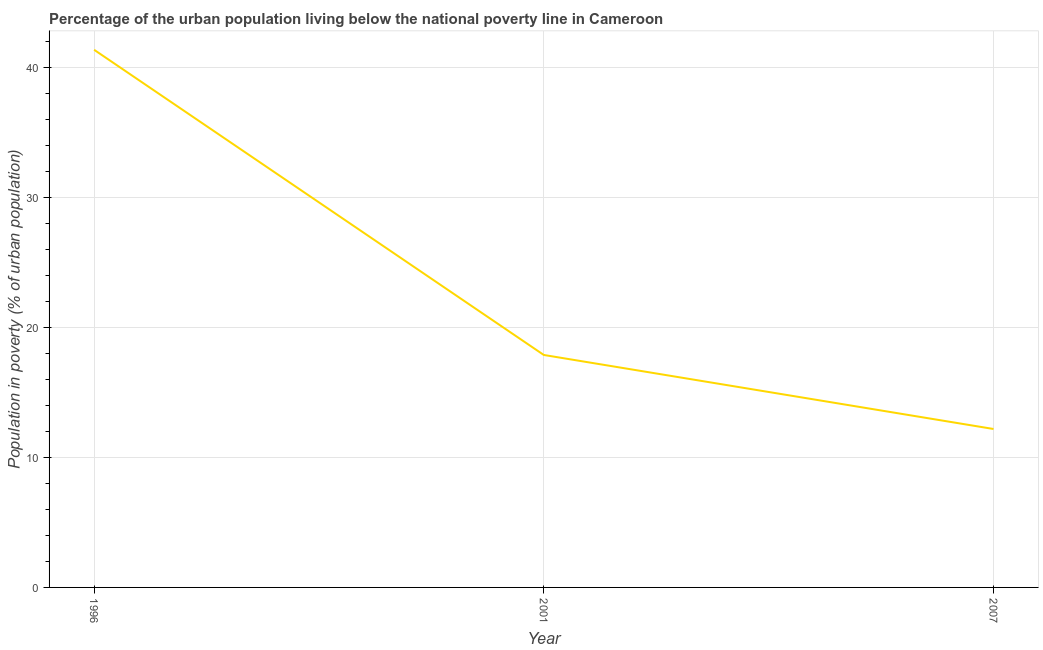What is the percentage of urban population living below poverty line in 1996?
Provide a short and direct response. 41.4. Across all years, what is the maximum percentage of urban population living below poverty line?
Your answer should be compact. 41.4. In which year was the percentage of urban population living below poverty line maximum?
Keep it short and to the point. 1996. In which year was the percentage of urban population living below poverty line minimum?
Provide a short and direct response. 2007. What is the sum of the percentage of urban population living below poverty line?
Your answer should be very brief. 71.5. What is the difference between the percentage of urban population living below poverty line in 1996 and 2007?
Your answer should be very brief. 29.2. What is the average percentage of urban population living below poverty line per year?
Offer a terse response. 23.83. What is the median percentage of urban population living below poverty line?
Keep it short and to the point. 17.9. In how many years, is the percentage of urban population living below poverty line greater than 18 %?
Keep it short and to the point. 1. Do a majority of the years between 1996 and 2007 (inclusive) have percentage of urban population living below poverty line greater than 6 %?
Make the answer very short. Yes. What is the ratio of the percentage of urban population living below poverty line in 2001 to that in 2007?
Give a very brief answer. 1.47. Is the sum of the percentage of urban population living below poverty line in 1996 and 2001 greater than the maximum percentage of urban population living below poverty line across all years?
Make the answer very short. Yes. What is the difference between the highest and the lowest percentage of urban population living below poverty line?
Make the answer very short. 29.2. In how many years, is the percentage of urban population living below poverty line greater than the average percentage of urban population living below poverty line taken over all years?
Your response must be concise. 1. Does the percentage of urban population living below poverty line monotonically increase over the years?
Provide a short and direct response. No. How many lines are there?
Provide a succinct answer. 1. What is the difference between two consecutive major ticks on the Y-axis?
Keep it short and to the point. 10. Are the values on the major ticks of Y-axis written in scientific E-notation?
Provide a succinct answer. No. What is the title of the graph?
Offer a very short reply. Percentage of the urban population living below the national poverty line in Cameroon. What is the label or title of the Y-axis?
Provide a short and direct response. Population in poverty (% of urban population). What is the Population in poverty (% of urban population) of 1996?
Offer a terse response. 41.4. What is the Population in poverty (% of urban population) of 2007?
Your answer should be compact. 12.2. What is the difference between the Population in poverty (% of urban population) in 1996 and 2001?
Give a very brief answer. 23.5. What is the difference between the Population in poverty (% of urban population) in 1996 and 2007?
Provide a short and direct response. 29.2. What is the ratio of the Population in poverty (% of urban population) in 1996 to that in 2001?
Your answer should be very brief. 2.31. What is the ratio of the Population in poverty (% of urban population) in 1996 to that in 2007?
Offer a very short reply. 3.39. What is the ratio of the Population in poverty (% of urban population) in 2001 to that in 2007?
Your answer should be compact. 1.47. 